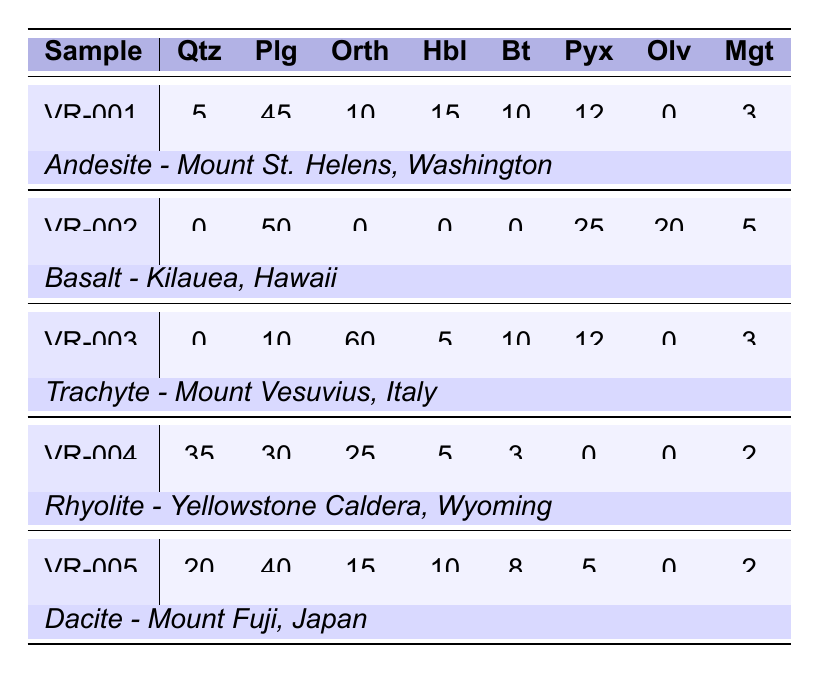What is the quartz content of the sample from Mount Fuji? The sample from Mount Fuji, identified as VR-005, shows a quartz content of 20.
Answer: 20 Which volcanic rock type contains the highest percentage of plagioclase? Among the samples, the Basalt from Kilauea (VR-002) has the highest plagioclase content at 50.
Answer: 50 How many samples have biotite content greater than 5? The samples from Mount St. Helens (VR-001) and Mount Fuji (VR-005) have biotite content of 10 and 8 respectively, totaling 2 samples.
Answer: 2 What is the average orthoclase content for the samples? The orthoclase values are 10 (VR-001) + 0 (VR-002) + 60 (VR-003) + 25 (VR-004) + 15 (VR-005) = 110. Dividing by the number of samples (5) gives an average of 22.
Answer: 22 Is there any sample that contains olivine? By examining the table, olivine is present in the Basalt from Kilauea (VR-002), which has an olivine content of 20. Thus, yes, there is a sample with olivine.
Answer: Yes Which rock type shows the highest total mineral content? Adding the mineral contents for each rock type: Andesite (VR-001) = 5 + 45 + 10 + 15 + 10 + 12 + 0 + 3 = 100, Basalt (VR-002) = 0 + 50 + 0 + 0 + 0 + 25 + 20 + 5 = 100, Trachyte (VR-003) = 0 + 10 + 60 + 5 + 10 + 12 + 0 + 3 = 100, Rhyolite (VR-004) = 35 + 30 + 25 + 5 + 3 + 0 + 0 + 2 = 100, Dacite (VR-005) = 20 + 40 + 15 + 10 + 8 + 5 + 0 + 2 = 100. All rock types have the same total mineral content of 100.
Answer: 100 Which sample has the lowest level of quartz? Looking at the quartz values, the Basalt from Kilauea (VR-002) has the lowest at 0.
Answer: 0 What is the difference in pyroxene content between the sample from Mount Vesuvius and the sample from Mount St. Helens? The pyroxene content for Mount Vesuvius (VR-003) is 12 and for Mount St. Helens (VR-001) is 12. Therefore, the difference is 12 - 12 = 0.
Answer: 0 How many minerals are at least present in the Rhyolite sample? The Rhyolite sample (VR-004) has quartz, plagioclase, orthoclase, hornblende, biotite, and magnetite with values greater than 0, totaling 6 minerals.
Answer: 6 What percentage does magnetite constitute in the Basalt sample? In the Basalt (VR-002), the total mineral content is 75 (0 + 50 + 0 + 0 + 0 + 25 + 20 + 5) and magnetite is 5. Therefore, the percentage is (5 / 75) * 100 = 6.67%.
Answer: 6.67% 